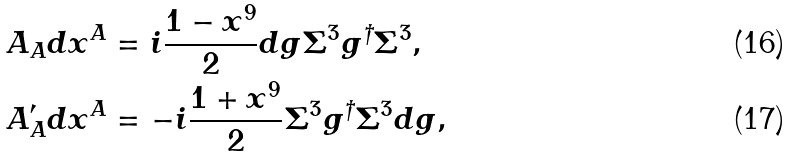Convert formula to latex. <formula><loc_0><loc_0><loc_500><loc_500>& A _ { A } d x ^ { A } = i \frac { 1 - x ^ { 9 } } { 2 } d g \Sigma ^ { 3 } g ^ { \dagger } \Sigma ^ { 3 } , \\ & A ^ { \prime } _ { A } d x ^ { A } = - i \frac { 1 + x ^ { 9 } } { 2 } \Sigma ^ { 3 } g ^ { \dagger } \Sigma ^ { 3 } d g ,</formula> 